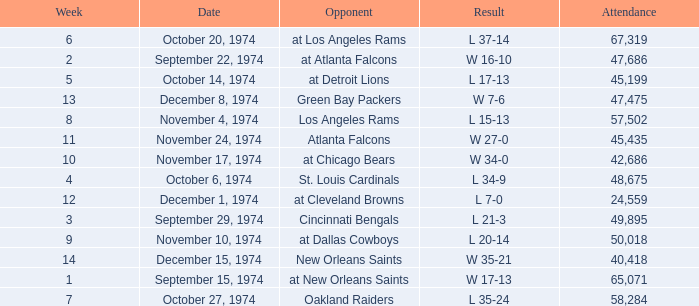Can you parse all the data within this table? {'header': ['Week', 'Date', 'Opponent', 'Result', 'Attendance'], 'rows': [['6', 'October 20, 1974', 'at Los Angeles Rams', 'L 37-14', '67,319'], ['2', 'September 22, 1974', 'at Atlanta Falcons', 'W 16-10', '47,686'], ['5', 'October 14, 1974', 'at Detroit Lions', 'L 17-13', '45,199'], ['13', 'December 8, 1974', 'Green Bay Packers', 'W 7-6', '47,475'], ['8', 'November 4, 1974', 'Los Angeles Rams', 'L 15-13', '57,502'], ['11', 'November 24, 1974', 'Atlanta Falcons', 'W 27-0', '45,435'], ['10', 'November 17, 1974', 'at Chicago Bears', 'W 34-0', '42,686'], ['4', 'October 6, 1974', 'St. Louis Cardinals', 'L 34-9', '48,675'], ['12', 'December 1, 1974', 'at Cleveland Browns', 'L 7-0', '24,559'], ['3', 'September 29, 1974', 'Cincinnati Bengals', 'L 21-3', '49,895'], ['9', 'November 10, 1974', 'at Dallas Cowboys', 'L 20-14', '50,018'], ['14', 'December 15, 1974', 'New Orleans Saints', 'W 35-21', '40,418'], ['1', 'September 15, 1974', 'at New Orleans Saints', 'W 17-13', '65,071'], ['7', 'October 27, 1974', 'Oakland Raiders', 'L 35-24', '58,284']]} What was the average attendance for games played at Atlanta Falcons? 47686.0. 